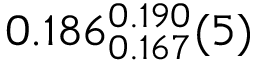<formula> <loc_0><loc_0><loc_500><loc_500>0 . 1 8 6 _ { 0 . 1 6 7 } ^ { 0 . 1 9 0 } ( 5 )</formula> 